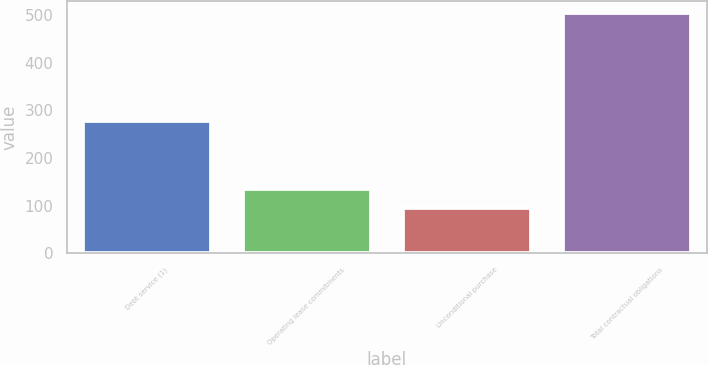Convert chart to OTSL. <chart><loc_0><loc_0><loc_500><loc_500><bar_chart><fcel>Debt service (1)<fcel>Operating lease commitments<fcel>Unconditional purchase<fcel>Total contractual obligations<nl><fcel>277.5<fcel>135.74<fcel>94.8<fcel>504.2<nl></chart> 